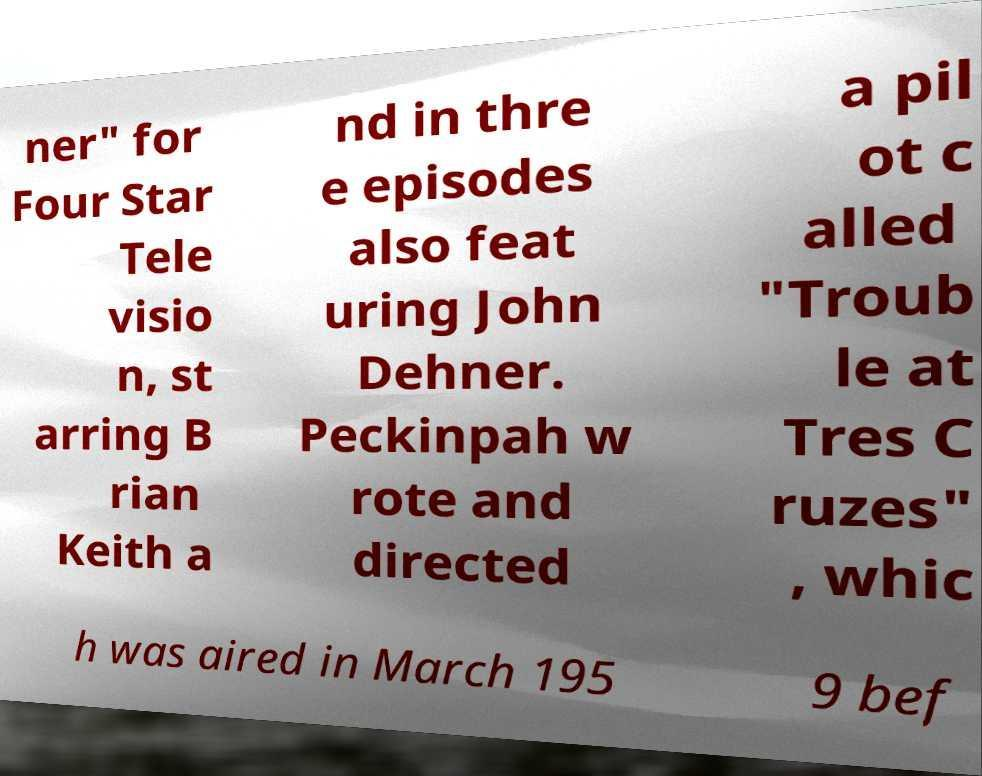I need the written content from this picture converted into text. Can you do that? ner" for Four Star Tele visio n, st arring B rian Keith a nd in thre e episodes also feat uring John Dehner. Peckinpah w rote and directed a pil ot c alled "Troub le at Tres C ruzes" , whic h was aired in March 195 9 bef 